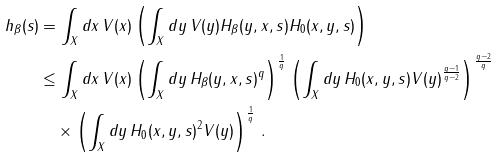<formula> <loc_0><loc_0><loc_500><loc_500>h _ { \beta } ( s ) & = \int _ { X } d x \, V ( x ) \left ( \int _ { X } d y \, V ( y ) H _ { \beta } ( y , x , s ) H _ { 0 } ( x , y , s ) \right ) \\ & \leq \int _ { X } d x \, V ( x ) \left ( \int _ { X } d y \, H _ { \beta } ( y , x , s ) ^ { q } \right ) ^ { \frac { 1 } { q } } \left ( \int _ { X } d y \, H _ { 0 } ( x , y , s ) V ( y ) ^ { \frac { q - 1 } { q - 2 } } \right ) ^ { \frac { q - 2 } q } \\ & \quad \times \left ( \int _ { X } d y \, H _ { 0 } ( x , y , s ) ^ { 2 } V ( y ) \right ) ^ { \frac { 1 } { q } } \, .</formula> 